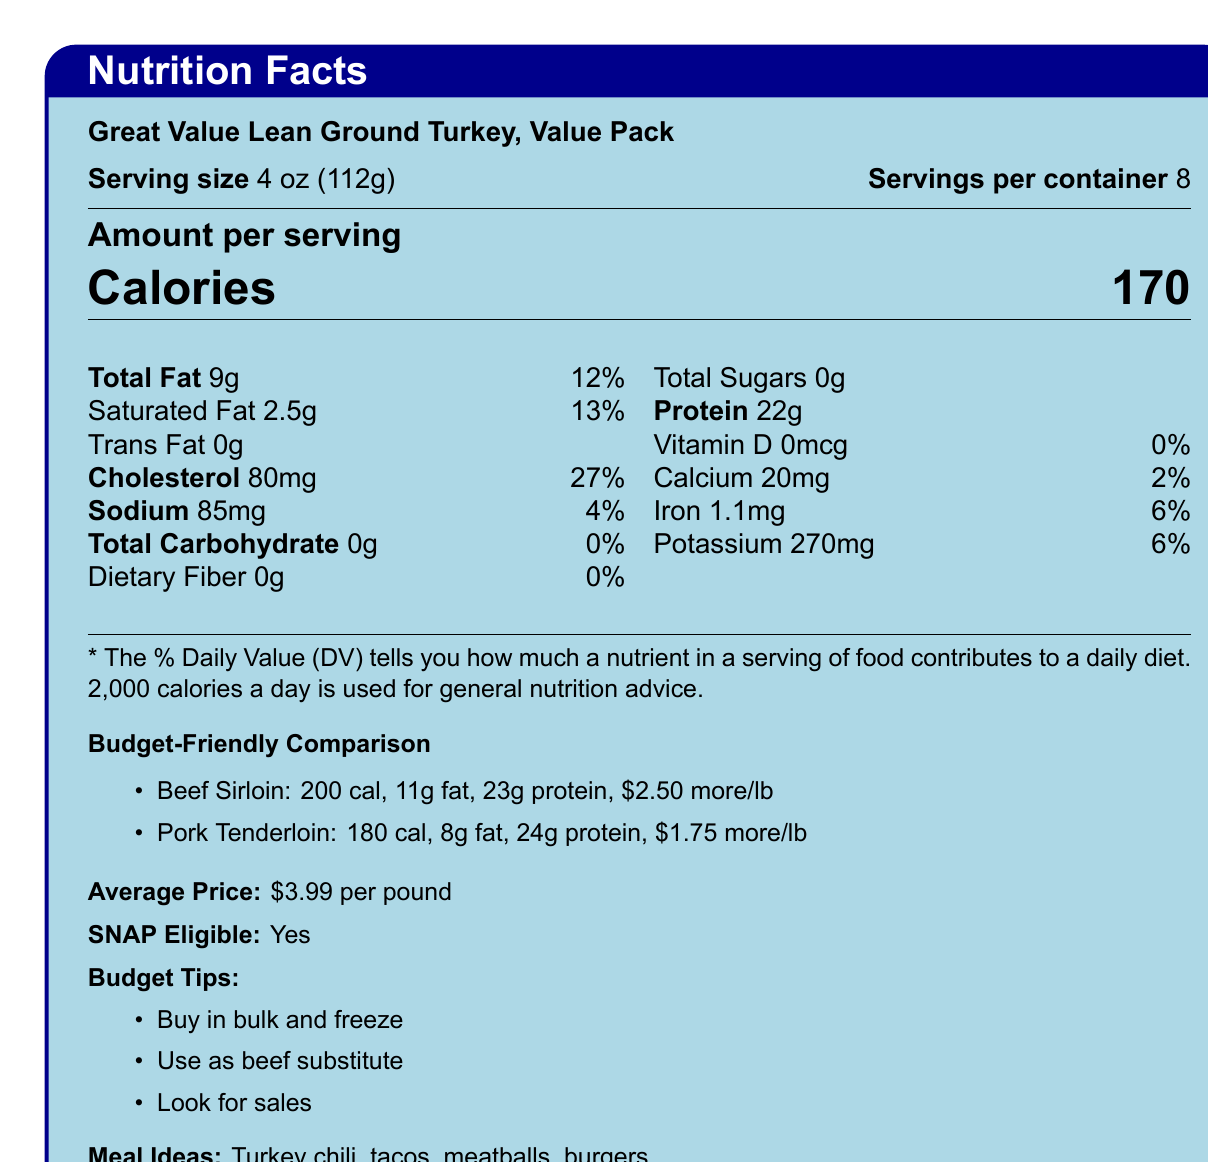who is the manufacturer of the product? The document does not provide information about the manufacturer.
Answer: Cannot be determined what is the serving size of the lean ground turkey? The document specifies the serving size as 4 oz (112g).
Answer: 4 oz (112g) how many calories are in a serving of lean ground turkey? The document states that each serving has 170 calories.
Answer: 170 calories what is the total fat content per serving? The total fat content per serving is listed as 9g in the document.
Answer: 9g how much sodium does one serving contain? The amount of sodium per serving is given as 85mg.
Answer: 85mg how many servings are in the container? The document indicates that there are 8 servings per container.
Answer: 8 which meat has the highest protein content per serving, as compared to the lean ground turkey? A. Lean Ground Turkey B. Beef Sirloin C. Pork Tenderloin Pork Tenderloin has 24g of protein, whereas Lean Ground Turkey has 22g and Beef Sirloin has 23g.
Answer: C how much more does beef sirloin cost per pound compared to the lean ground turkey? The document states that beef sirloin costs $2.50 more per pound than the lean ground turkey.
Answer: $2.50 more per pound which option is lower in calories: lean ground turkey, beef sirloin, or pork tenderloin? A. Lean Ground Turkey B. Beef Sirloin C. Pork Tenderloin Lean Ground Turkey has 170 calories, which is less than Beef Sirloin (200 calories) and Pork Tenderloin (180 calories).
Answer: A how much cholesterol is in a single serving of lean ground turkey? The document lists the amount of cholesterol per serving as 80mg.
Answer: 80mg is this product eligible for purchase with SNAP benefits? The document explicitly states that the product is eligible for purchase with SNAP benefits.
Answer: Yes what is the main idea of the document? The document includes detailed nutrition information, cost comparisons, tips for budget-conscious shoppers, health benefits, and available meal ideas for Great Value Lean Ground Turkey.
Answer: The document provides nutritional facts for Great Value Lean Ground Turkey, compares it to other meats like beef sirloin and pork tenderloin, offers budget-friendly tips, and suggests meal ideas. what is the daily value percentage of iron in one serving? The document shows that the daily value percentage of iron per serving is 6%.
Answer: 6% how can you save money when buying lean ground turkey? List at least two tips. The document offers tips such as buying in bulk and freezing portions or looking for sales and stocking up.
Answer: Buy in bulk and freeze portions, look for sales and stock up when prices are low what type of recipes can you make with lean ground turkey? The document suggests several meal ideas including turkey chili, tacos, meatballs, and burgers.
Answer: Turkey chili, Turkey tacos, Turkey meatballs, Turkey burgers what is the average price per pound of the lean ground turkey? The document mentions that the average price is $3.99 per pound.
Answer: $3.99 per pound does the ground turkey contain any dietary fiber? The document states that the total dietary fiber content is 0g.
Answer: No what stores offer this lean ground turkey value pack? The document lists stores such as Walmart, Aldi, Food Lion, and local grocery stores where the product can be found.
Answer: Walmart, Aldi, Food Lion, Local grocery stores 